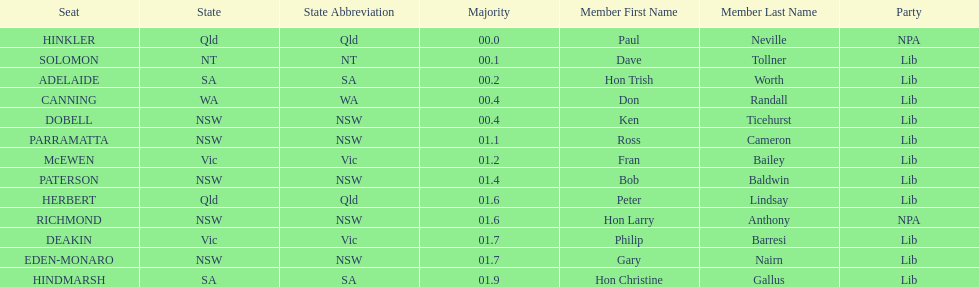What was the total majority that the dobell seat had? 00.4. 